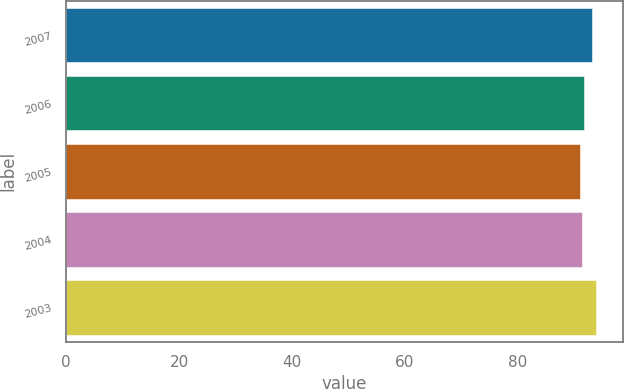<chart> <loc_0><loc_0><loc_500><loc_500><bar_chart><fcel>2007<fcel>2006<fcel>2005<fcel>2004<fcel>2003<nl><fcel>93.2<fcel>91.7<fcel>91<fcel>91.4<fcel>93.9<nl></chart> 